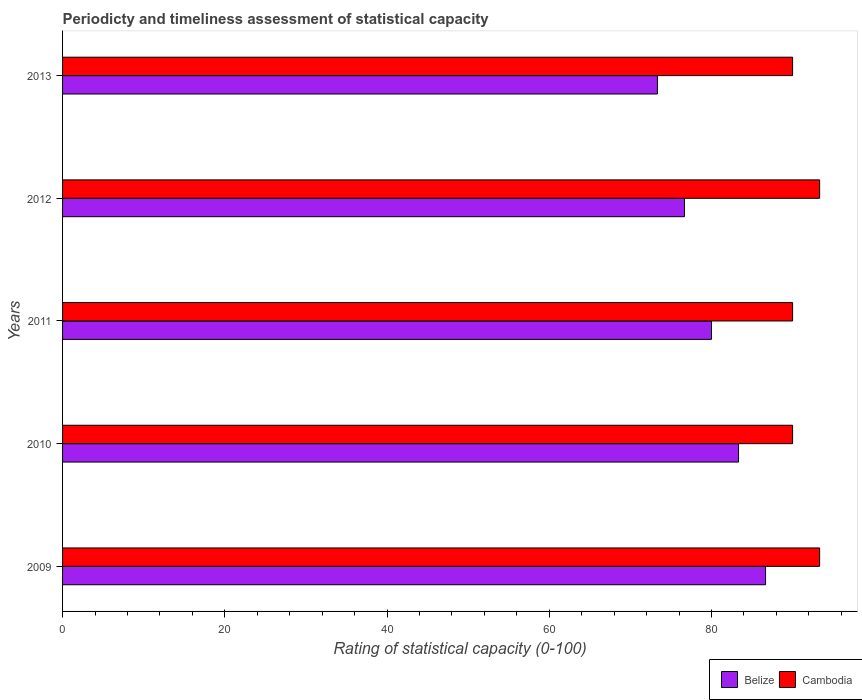How many groups of bars are there?
Ensure brevity in your answer.  5. How many bars are there on the 1st tick from the top?
Your response must be concise. 2. How many bars are there on the 5th tick from the bottom?
Offer a terse response. 2. What is the rating of statistical capacity in Cambodia in 2010?
Ensure brevity in your answer.  90. Across all years, what is the maximum rating of statistical capacity in Cambodia?
Ensure brevity in your answer.  93.33. In which year was the rating of statistical capacity in Cambodia maximum?
Your answer should be very brief. 2009. What is the total rating of statistical capacity in Cambodia in the graph?
Give a very brief answer. 456.67. What is the difference between the rating of statistical capacity in Cambodia in 2011 and that in 2012?
Provide a succinct answer. -3.33. What is the difference between the rating of statistical capacity in Belize in 2010 and the rating of statistical capacity in Cambodia in 2012?
Offer a very short reply. -10. What is the average rating of statistical capacity in Cambodia per year?
Your response must be concise. 91.33. In the year 2011, what is the difference between the rating of statistical capacity in Belize and rating of statistical capacity in Cambodia?
Give a very brief answer. -10. In how many years, is the rating of statistical capacity in Cambodia greater than 28 ?
Make the answer very short. 5. What is the ratio of the rating of statistical capacity in Belize in 2009 to that in 2010?
Offer a terse response. 1.04. Is the difference between the rating of statistical capacity in Belize in 2009 and 2012 greater than the difference between the rating of statistical capacity in Cambodia in 2009 and 2012?
Your answer should be very brief. Yes. What is the difference between the highest and the second highest rating of statistical capacity in Belize?
Offer a very short reply. 3.33. What is the difference between the highest and the lowest rating of statistical capacity in Belize?
Keep it short and to the point. 13.33. What does the 2nd bar from the top in 2009 represents?
Give a very brief answer. Belize. What does the 1st bar from the bottom in 2012 represents?
Offer a terse response. Belize. How many years are there in the graph?
Offer a terse response. 5. Are the values on the major ticks of X-axis written in scientific E-notation?
Your answer should be very brief. No. Where does the legend appear in the graph?
Make the answer very short. Bottom right. How many legend labels are there?
Provide a succinct answer. 2. What is the title of the graph?
Provide a succinct answer. Periodicty and timeliness assessment of statistical capacity. Does "Burkina Faso" appear as one of the legend labels in the graph?
Your answer should be compact. No. What is the label or title of the X-axis?
Make the answer very short. Rating of statistical capacity (0-100). What is the label or title of the Y-axis?
Offer a terse response. Years. What is the Rating of statistical capacity (0-100) of Belize in 2009?
Make the answer very short. 86.67. What is the Rating of statistical capacity (0-100) of Cambodia in 2009?
Keep it short and to the point. 93.33. What is the Rating of statistical capacity (0-100) in Belize in 2010?
Make the answer very short. 83.33. What is the Rating of statistical capacity (0-100) in Belize in 2011?
Make the answer very short. 80. What is the Rating of statistical capacity (0-100) of Cambodia in 2011?
Give a very brief answer. 90. What is the Rating of statistical capacity (0-100) in Belize in 2012?
Provide a short and direct response. 76.67. What is the Rating of statistical capacity (0-100) in Cambodia in 2012?
Give a very brief answer. 93.33. What is the Rating of statistical capacity (0-100) in Belize in 2013?
Offer a very short reply. 73.33. What is the Rating of statistical capacity (0-100) of Cambodia in 2013?
Give a very brief answer. 90. Across all years, what is the maximum Rating of statistical capacity (0-100) in Belize?
Offer a very short reply. 86.67. Across all years, what is the maximum Rating of statistical capacity (0-100) of Cambodia?
Your response must be concise. 93.33. Across all years, what is the minimum Rating of statistical capacity (0-100) in Belize?
Offer a very short reply. 73.33. What is the total Rating of statistical capacity (0-100) of Belize in the graph?
Give a very brief answer. 400. What is the total Rating of statistical capacity (0-100) of Cambodia in the graph?
Your answer should be very brief. 456.67. What is the difference between the Rating of statistical capacity (0-100) in Belize in 2009 and that in 2010?
Your answer should be compact. 3.33. What is the difference between the Rating of statistical capacity (0-100) of Cambodia in 2009 and that in 2012?
Your answer should be compact. 0. What is the difference between the Rating of statistical capacity (0-100) of Belize in 2009 and that in 2013?
Your response must be concise. 13.33. What is the difference between the Rating of statistical capacity (0-100) in Cambodia in 2009 and that in 2013?
Offer a terse response. 3.33. What is the difference between the Rating of statistical capacity (0-100) in Cambodia in 2010 and that in 2011?
Keep it short and to the point. 0. What is the difference between the Rating of statistical capacity (0-100) of Belize in 2010 and that in 2012?
Your response must be concise. 6.67. What is the difference between the Rating of statistical capacity (0-100) in Cambodia in 2010 and that in 2012?
Your response must be concise. -3.33. What is the difference between the Rating of statistical capacity (0-100) in Cambodia in 2011 and that in 2013?
Give a very brief answer. 0. What is the difference between the Rating of statistical capacity (0-100) in Belize in 2009 and the Rating of statistical capacity (0-100) in Cambodia in 2011?
Keep it short and to the point. -3.33. What is the difference between the Rating of statistical capacity (0-100) in Belize in 2009 and the Rating of statistical capacity (0-100) in Cambodia in 2012?
Your answer should be very brief. -6.67. What is the difference between the Rating of statistical capacity (0-100) in Belize in 2010 and the Rating of statistical capacity (0-100) in Cambodia in 2011?
Provide a succinct answer. -6.67. What is the difference between the Rating of statistical capacity (0-100) of Belize in 2010 and the Rating of statistical capacity (0-100) of Cambodia in 2013?
Give a very brief answer. -6.67. What is the difference between the Rating of statistical capacity (0-100) in Belize in 2011 and the Rating of statistical capacity (0-100) in Cambodia in 2012?
Ensure brevity in your answer.  -13.33. What is the difference between the Rating of statistical capacity (0-100) of Belize in 2011 and the Rating of statistical capacity (0-100) of Cambodia in 2013?
Make the answer very short. -10. What is the difference between the Rating of statistical capacity (0-100) in Belize in 2012 and the Rating of statistical capacity (0-100) in Cambodia in 2013?
Provide a succinct answer. -13.33. What is the average Rating of statistical capacity (0-100) in Belize per year?
Offer a terse response. 80. What is the average Rating of statistical capacity (0-100) of Cambodia per year?
Ensure brevity in your answer.  91.33. In the year 2009, what is the difference between the Rating of statistical capacity (0-100) of Belize and Rating of statistical capacity (0-100) of Cambodia?
Give a very brief answer. -6.67. In the year 2010, what is the difference between the Rating of statistical capacity (0-100) in Belize and Rating of statistical capacity (0-100) in Cambodia?
Keep it short and to the point. -6.67. In the year 2012, what is the difference between the Rating of statistical capacity (0-100) in Belize and Rating of statistical capacity (0-100) in Cambodia?
Make the answer very short. -16.67. In the year 2013, what is the difference between the Rating of statistical capacity (0-100) of Belize and Rating of statistical capacity (0-100) of Cambodia?
Your answer should be compact. -16.67. What is the ratio of the Rating of statistical capacity (0-100) of Belize in 2009 to that in 2010?
Give a very brief answer. 1.04. What is the ratio of the Rating of statistical capacity (0-100) of Cambodia in 2009 to that in 2010?
Your answer should be very brief. 1.04. What is the ratio of the Rating of statistical capacity (0-100) of Cambodia in 2009 to that in 2011?
Make the answer very short. 1.04. What is the ratio of the Rating of statistical capacity (0-100) of Belize in 2009 to that in 2012?
Ensure brevity in your answer.  1.13. What is the ratio of the Rating of statistical capacity (0-100) in Belize in 2009 to that in 2013?
Your answer should be very brief. 1.18. What is the ratio of the Rating of statistical capacity (0-100) in Belize in 2010 to that in 2011?
Provide a succinct answer. 1.04. What is the ratio of the Rating of statistical capacity (0-100) in Cambodia in 2010 to that in 2011?
Provide a short and direct response. 1. What is the ratio of the Rating of statistical capacity (0-100) in Belize in 2010 to that in 2012?
Your answer should be compact. 1.09. What is the ratio of the Rating of statistical capacity (0-100) of Cambodia in 2010 to that in 2012?
Offer a terse response. 0.96. What is the ratio of the Rating of statistical capacity (0-100) in Belize in 2010 to that in 2013?
Ensure brevity in your answer.  1.14. What is the ratio of the Rating of statistical capacity (0-100) in Belize in 2011 to that in 2012?
Your answer should be very brief. 1.04. What is the ratio of the Rating of statistical capacity (0-100) of Cambodia in 2011 to that in 2012?
Your answer should be compact. 0.96. What is the ratio of the Rating of statistical capacity (0-100) in Belize in 2012 to that in 2013?
Provide a succinct answer. 1.05. What is the difference between the highest and the second highest Rating of statistical capacity (0-100) of Cambodia?
Your response must be concise. 0. What is the difference between the highest and the lowest Rating of statistical capacity (0-100) of Belize?
Offer a very short reply. 13.33. 